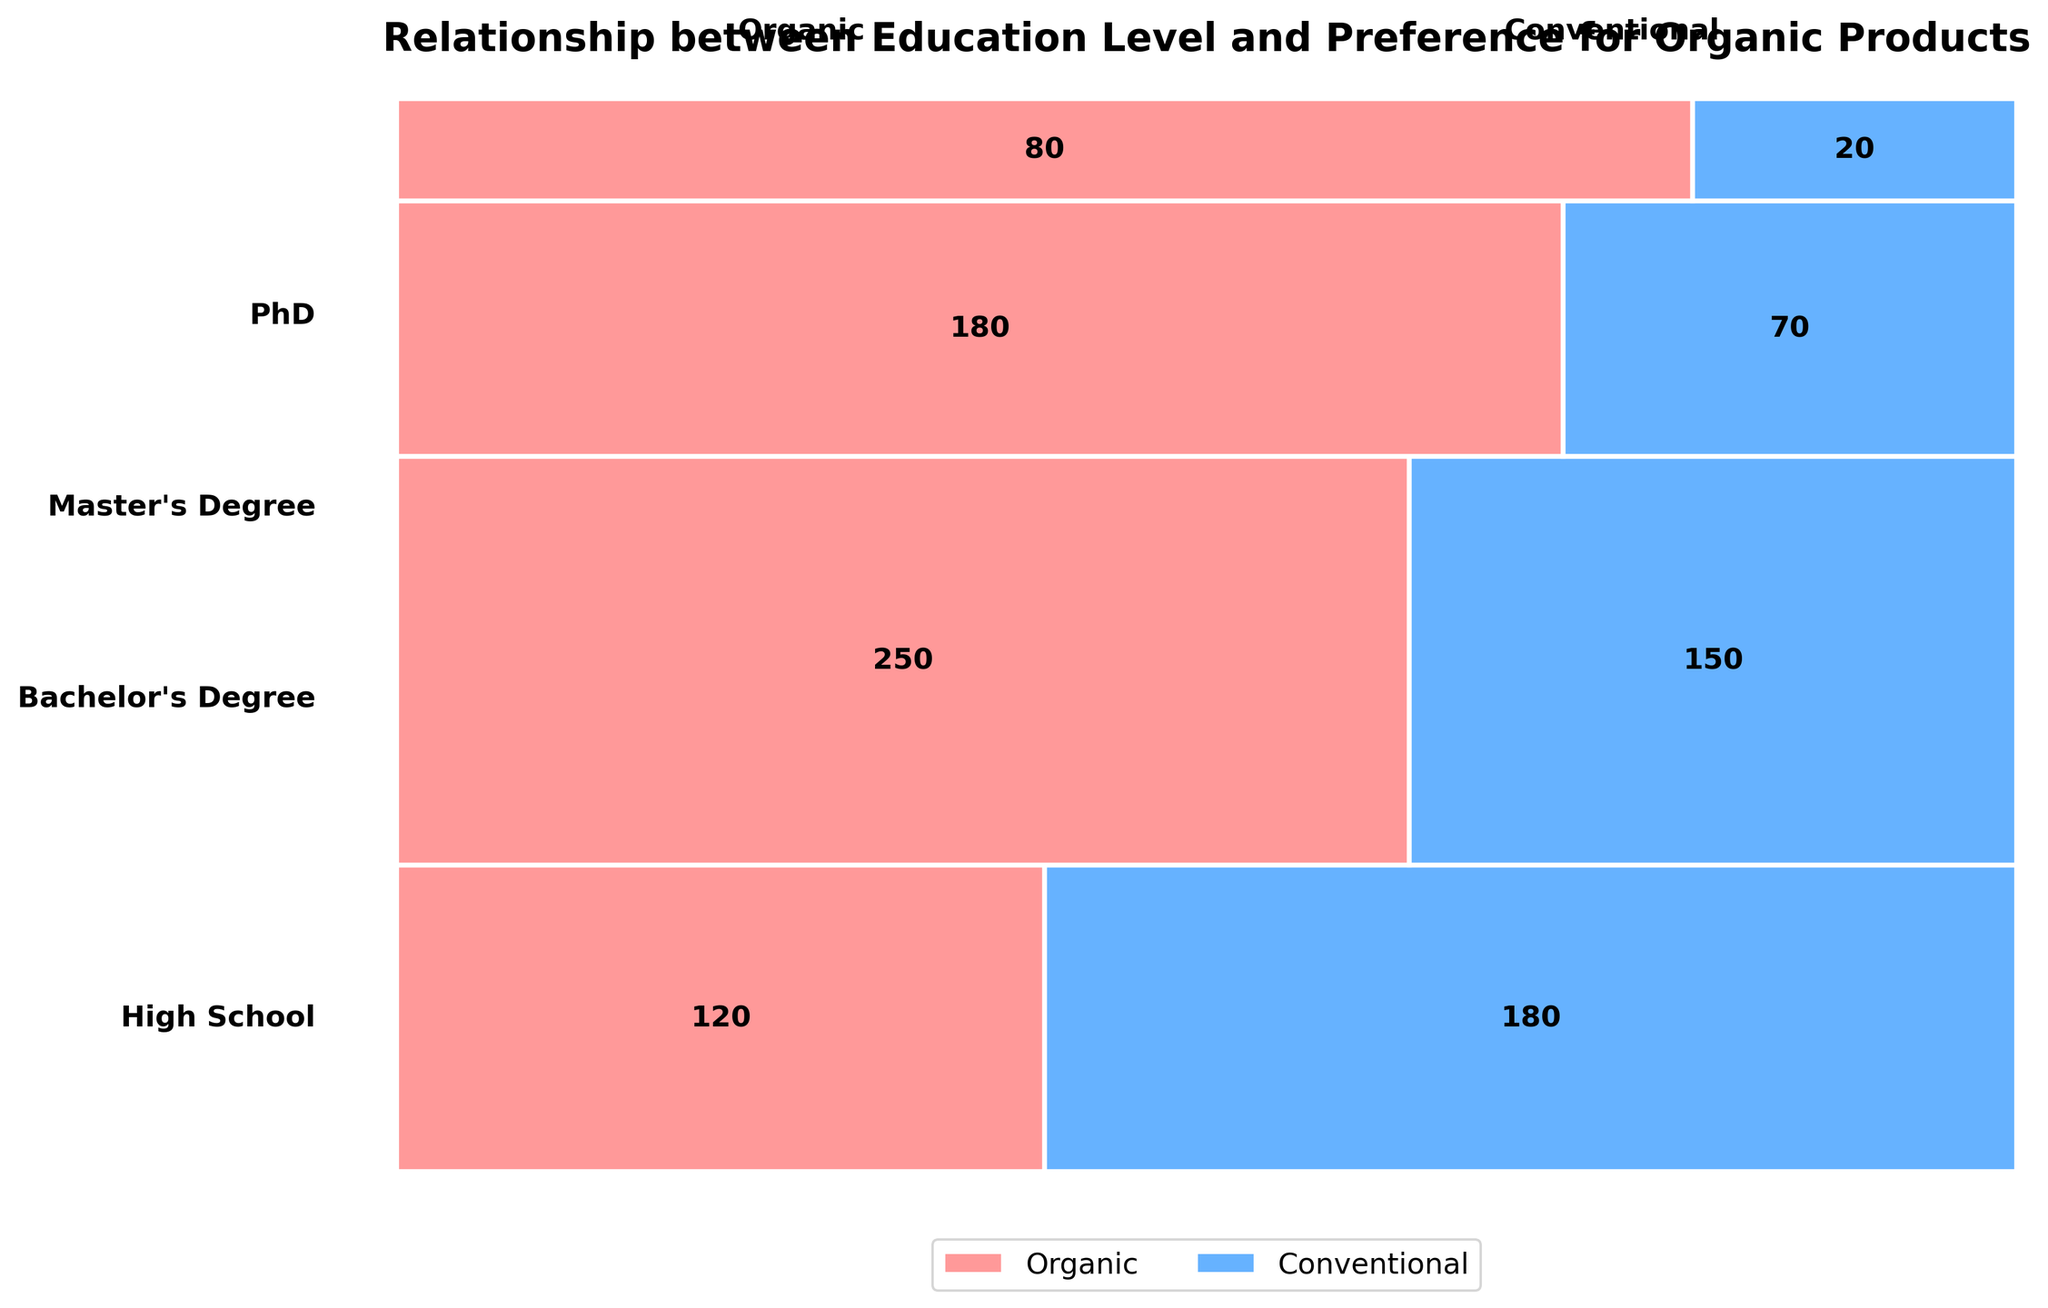How many people with a Bachelor's degree prefer organic products? Look for the rectangle corresponding to "Bachelor's Degree" and "Organic". The number is annotated within the rectangle.
Answer: 250 What is the total number of PhD holders surveyed in the data? Add the counts of PhD holders who prefer organic and conventional products: 80 (organic) + 20 (conventional).
Answer: 100 Which education level has the largest proportion of organic product preference? Compare the sizes of the "Organic" rectangles for each education level. The largest proportion is found in the bachelor's degree section.
Answer: Bachelor's Degree How does the preference for organic products change as education level increases from High School to Master's Degree? Observe the progression of the organic preference rectangles from bottom (High School) to Master's Degree to see how they change in size. The proportion increases as the education level rises. High School: 120 out of 300, Bachelor's: 250 out of 400, Master's: 180 out of 250.
Answer: Increases What is the ratio of conventional to organic preference among Master's degree holders? Count the number of conventional and organic preference holders with a Master's degree and compare them. Conventional: 70, Organic: 180. Ratio = 70/180.
Answer: 7:18 Which educational group has the smallest number of conventional product preferences? Compare the sizes of the "Conventional" rectangles across all education levels to find the smallest. It's the PhD group with 20 people.
Answer: PhD What percentage of high school graduates prefer organic products? Out of 300 high school graduates surveyed, 120 prefer organic. Calculate 120/300 * 100.
Answer: 40% Looking at the plot, which product preference shows a consistent decrease as education level increases? Examine the sizes of both product preference rectangles across increasing education levels. Conventional preference decreases consistently.
Answer: Conventional If a new survey showed 100 high school graduates prefer conventional products now instead of 180, how would this affect the proportions for the high school group? Recalculate the proportions: Total high school respondents = 120 (organic) + 100 (conventional) = 220. Organic proportion: 120/220, Conventional proportion: 100/220.
Answer: Higher organic proportion Which education level has the most balanced preference between organic and conventional products? Look for the education level where the sizes of the organic and conventional rectangles are most similar in proportion. The closest is the Bachelor's Degree group: 250 organic, 150 conventional.
Answer: Bachelor's Degree 